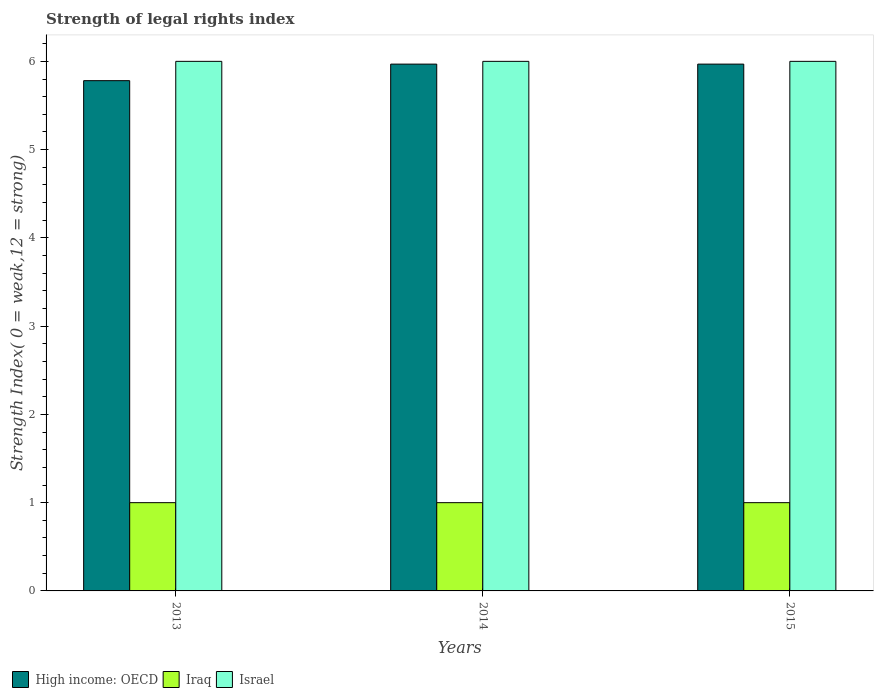Are the number of bars per tick equal to the number of legend labels?
Provide a succinct answer. Yes. Are the number of bars on each tick of the X-axis equal?
Ensure brevity in your answer.  Yes. Across all years, what is the maximum strength index in High income: OECD?
Your answer should be compact. 5.97. Across all years, what is the minimum strength index in Iraq?
Offer a very short reply. 1. What is the total strength index in Israel in the graph?
Offer a terse response. 18. What is the difference between the strength index in Israel in 2013 and that in 2015?
Offer a terse response. 0. What is the difference between the strength index in Israel in 2014 and the strength index in Iraq in 2013?
Provide a short and direct response. 5. What is the average strength index in Israel per year?
Provide a short and direct response. 6. In the year 2015, what is the difference between the strength index in Israel and strength index in High income: OECD?
Offer a terse response. 0.03. What is the ratio of the strength index in High income: OECD in 2013 to that in 2015?
Provide a short and direct response. 0.97. Is the strength index in Iraq in 2014 less than that in 2015?
Give a very brief answer. No. Is the difference between the strength index in Israel in 2013 and 2015 greater than the difference between the strength index in High income: OECD in 2013 and 2015?
Your answer should be compact. Yes. What is the difference between the highest and the second highest strength index in High income: OECD?
Ensure brevity in your answer.  0. In how many years, is the strength index in High income: OECD greater than the average strength index in High income: OECD taken over all years?
Your response must be concise. 2. What does the 3rd bar from the left in 2013 represents?
Offer a very short reply. Israel. What does the 1st bar from the right in 2014 represents?
Provide a short and direct response. Israel. Is it the case that in every year, the sum of the strength index in Iraq and strength index in Israel is greater than the strength index in High income: OECD?
Give a very brief answer. Yes. What is the difference between two consecutive major ticks on the Y-axis?
Keep it short and to the point. 1. Are the values on the major ticks of Y-axis written in scientific E-notation?
Provide a short and direct response. No. Where does the legend appear in the graph?
Give a very brief answer. Bottom left. How are the legend labels stacked?
Your answer should be compact. Horizontal. What is the title of the graph?
Your answer should be compact. Strength of legal rights index. What is the label or title of the Y-axis?
Give a very brief answer. Strength Index( 0 = weak,12 = strong). What is the Strength Index( 0 = weak,12 = strong) in High income: OECD in 2013?
Keep it short and to the point. 5.78. What is the Strength Index( 0 = weak,12 = strong) of High income: OECD in 2014?
Offer a terse response. 5.97. What is the Strength Index( 0 = weak,12 = strong) in Iraq in 2014?
Your answer should be very brief. 1. What is the Strength Index( 0 = weak,12 = strong) of High income: OECD in 2015?
Your answer should be compact. 5.97. What is the Strength Index( 0 = weak,12 = strong) of Israel in 2015?
Provide a succinct answer. 6. Across all years, what is the maximum Strength Index( 0 = weak,12 = strong) of High income: OECD?
Keep it short and to the point. 5.97. Across all years, what is the maximum Strength Index( 0 = weak,12 = strong) of Iraq?
Ensure brevity in your answer.  1. Across all years, what is the maximum Strength Index( 0 = weak,12 = strong) in Israel?
Offer a terse response. 6. Across all years, what is the minimum Strength Index( 0 = weak,12 = strong) of High income: OECD?
Your answer should be compact. 5.78. Across all years, what is the minimum Strength Index( 0 = weak,12 = strong) in Israel?
Your response must be concise. 6. What is the total Strength Index( 0 = weak,12 = strong) of High income: OECD in the graph?
Your response must be concise. 17.72. What is the total Strength Index( 0 = weak,12 = strong) in Israel in the graph?
Provide a succinct answer. 18. What is the difference between the Strength Index( 0 = weak,12 = strong) of High income: OECD in 2013 and that in 2014?
Keep it short and to the point. -0.19. What is the difference between the Strength Index( 0 = weak,12 = strong) of Israel in 2013 and that in 2014?
Ensure brevity in your answer.  0. What is the difference between the Strength Index( 0 = weak,12 = strong) in High income: OECD in 2013 and that in 2015?
Provide a short and direct response. -0.19. What is the difference between the Strength Index( 0 = weak,12 = strong) in Iraq in 2013 and that in 2015?
Your answer should be compact. 0. What is the difference between the Strength Index( 0 = weak,12 = strong) in Israel in 2013 and that in 2015?
Your response must be concise. 0. What is the difference between the Strength Index( 0 = weak,12 = strong) of High income: OECD in 2014 and that in 2015?
Provide a succinct answer. 0. What is the difference between the Strength Index( 0 = weak,12 = strong) in Iraq in 2014 and that in 2015?
Provide a short and direct response. 0. What is the difference between the Strength Index( 0 = weak,12 = strong) in Israel in 2014 and that in 2015?
Your response must be concise. 0. What is the difference between the Strength Index( 0 = weak,12 = strong) of High income: OECD in 2013 and the Strength Index( 0 = weak,12 = strong) of Iraq in 2014?
Make the answer very short. 4.78. What is the difference between the Strength Index( 0 = weak,12 = strong) of High income: OECD in 2013 and the Strength Index( 0 = weak,12 = strong) of Israel in 2014?
Provide a short and direct response. -0.22. What is the difference between the Strength Index( 0 = weak,12 = strong) of Iraq in 2013 and the Strength Index( 0 = weak,12 = strong) of Israel in 2014?
Ensure brevity in your answer.  -5. What is the difference between the Strength Index( 0 = weak,12 = strong) in High income: OECD in 2013 and the Strength Index( 0 = weak,12 = strong) in Iraq in 2015?
Ensure brevity in your answer.  4.78. What is the difference between the Strength Index( 0 = weak,12 = strong) in High income: OECD in 2013 and the Strength Index( 0 = weak,12 = strong) in Israel in 2015?
Ensure brevity in your answer.  -0.22. What is the difference between the Strength Index( 0 = weak,12 = strong) of High income: OECD in 2014 and the Strength Index( 0 = weak,12 = strong) of Iraq in 2015?
Provide a succinct answer. 4.97. What is the difference between the Strength Index( 0 = weak,12 = strong) in High income: OECD in 2014 and the Strength Index( 0 = weak,12 = strong) in Israel in 2015?
Your answer should be very brief. -0.03. What is the average Strength Index( 0 = weak,12 = strong) in High income: OECD per year?
Offer a very short reply. 5.91. What is the average Strength Index( 0 = weak,12 = strong) of Israel per year?
Give a very brief answer. 6. In the year 2013, what is the difference between the Strength Index( 0 = weak,12 = strong) of High income: OECD and Strength Index( 0 = weak,12 = strong) of Iraq?
Give a very brief answer. 4.78. In the year 2013, what is the difference between the Strength Index( 0 = weak,12 = strong) of High income: OECD and Strength Index( 0 = weak,12 = strong) of Israel?
Offer a terse response. -0.22. In the year 2013, what is the difference between the Strength Index( 0 = weak,12 = strong) of Iraq and Strength Index( 0 = weak,12 = strong) of Israel?
Offer a terse response. -5. In the year 2014, what is the difference between the Strength Index( 0 = weak,12 = strong) in High income: OECD and Strength Index( 0 = weak,12 = strong) in Iraq?
Your answer should be very brief. 4.97. In the year 2014, what is the difference between the Strength Index( 0 = weak,12 = strong) of High income: OECD and Strength Index( 0 = weak,12 = strong) of Israel?
Your response must be concise. -0.03. In the year 2015, what is the difference between the Strength Index( 0 = weak,12 = strong) in High income: OECD and Strength Index( 0 = weak,12 = strong) in Iraq?
Your response must be concise. 4.97. In the year 2015, what is the difference between the Strength Index( 0 = weak,12 = strong) of High income: OECD and Strength Index( 0 = weak,12 = strong) of Israel?
Make the answer very short. -0.03. What is the ratio of the Strength Index( 0 = weak,12 = strong) in High income: OECD in 2013 to that in 2014?
Provide a short and direct response. 0.97. What is the ratio of the Strength Index( 0 = weak,12 = strong) in Israel in 2013 to that in 2014?
Your answer should be very brief. 1. What is the ratio of the Strength Index( 0 = weak,12 = strong) in High income: OECD in 2013 to that in 2015?
Ensure brevity in your answer.  0.97. What is the ratio of the Strength Index( 0 = weak,12 = strong) of Israel in 2013 to that in 2015?
Offer a very short reply. 1. What is the ratio of the Strength Index( 0 = weak,12 = strong) in Iraq in 2014 to that in 2015?
Keep it short and to the point. 1. What is the difference between the highest and the second highest Strength Index( 0 = weak,12 = strong) of High income: OECD?
Your response must be concise. 0. What is the difference between the highest and the lowest Strength Index( 0 = weak,12 = strong) of High income: OECD?
Ensure brevity in your answer.  0.19. What is the difference between the highest and the lowest Strength Index( 0 = weak,12 = strong) of Israel?
Your answer should be very brief. 0. 